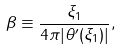Convert formula to latex. <formula><loc_0><loc_0><loc_500><loc_500>\beta \equiv \frac { \xi _ { 1 } } { 4 \pi | \theta ^ { \prime } ( \xi _ { 1 } ) | } ,</formula> 